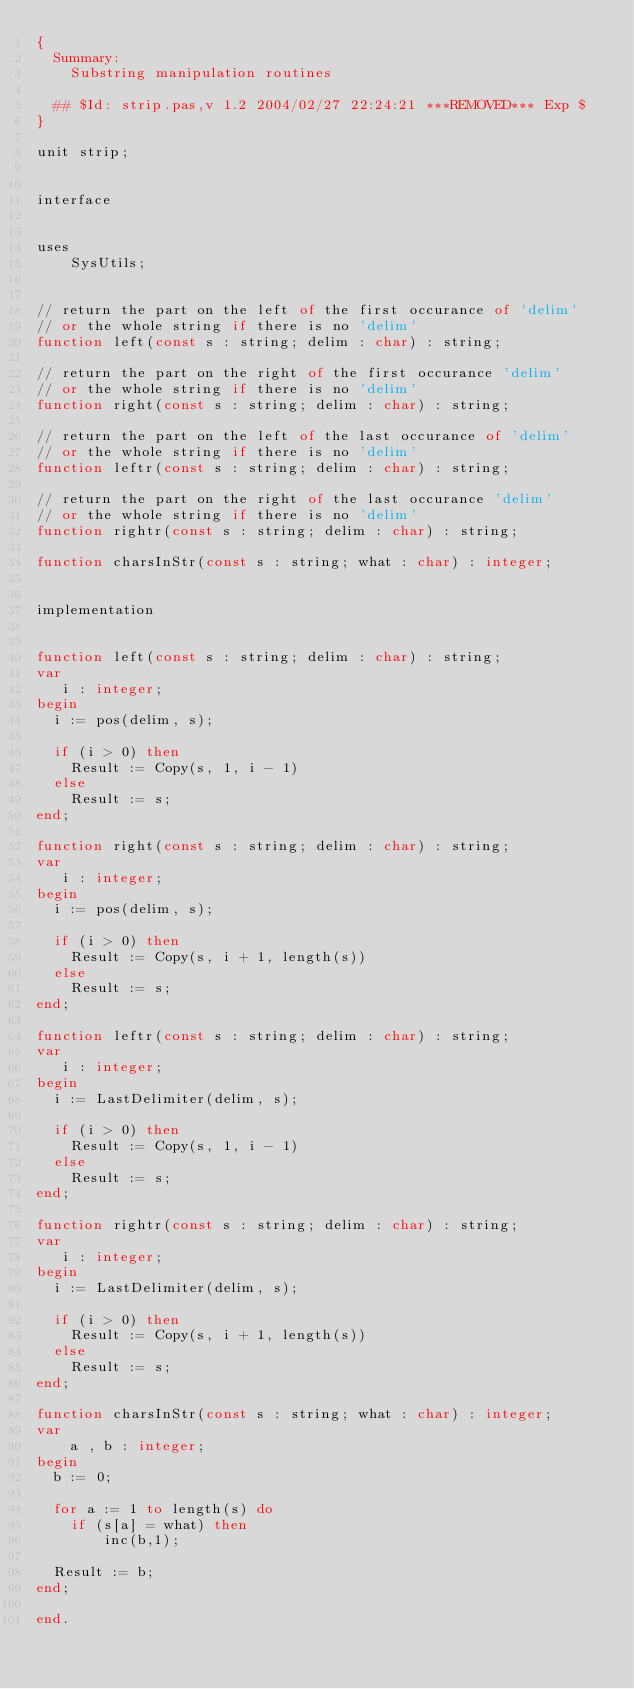Convert code to text. <code><loc_0><loc_0><loc_500><loc_500><_Pascal_>{
  Summary:
  	Substring manipulation routines
  	
  ## $Id: strip.pas,v 1.2 2004/02/27 22:24:21 ***REMOVED*** Exp $
}

unit strip;


interface


uses 
	SysUtils;
	

// return the part on the left of the first occurance of 'delim'
// or the whole string if there is no 'delim'
function left(const s : string; delim : char) : string;

// return the part on the right of the first occurance 'delim'
// or the whole string if there is no 'delim'
function right(const s : string; delim : char) : string;

// return the part on the left of the last occurance of 'delim'
// or the whole string if there is no 'delim'
function leftr(const s : string; delim : char) : string;

// return the part on the right of the last occurance 'delim'
// or the whole string if there is no 'delim'
function rightr(const s : string; delim : char) : string;

function charsInStr(const s : string; what : char) : integer;


implementation


function left(const s : string; delim : char) : string;
var
   i : integer;
begin
  i := pos(delim, s);

  if (i > 0) then
    Result := Copy(s, 1, i - 1)
  else
    Result := s;
end;

function right(const s : string; delim : char) : string;
var
   i : integer;
begin
  i := pos(delim, s);

  if (i > 0) then
    Result := Copy(s, i + 1, length(s))
  else
    Result := s;
end;

function leftr(const s : string; delim : char) : string;
var
   i : integer;
begin
  i := LastDelimiter(delim, s);

  if (i > 0) then
    Result := Copy(s, 1, i - 1)
  else
    Result := s;
end;

function rightr(const s : string; delim : char) : string;
var
   i : integer;
begin
  i := LastDelimiter(delim, s);

  if (i > 0) then
    Result := Copy(s, i + 1, length(s))
  else
    Result := s;
end;

function charsInStr(const s : string; what : char) : integer;
var 
	a , b : integer;
begin
  b := 0;
  
  for a := 1 to length(s) do
   	if (s[a] = what) then 
   		inc(b,1);
   		
  Result := b;
end;

end.
</code> 